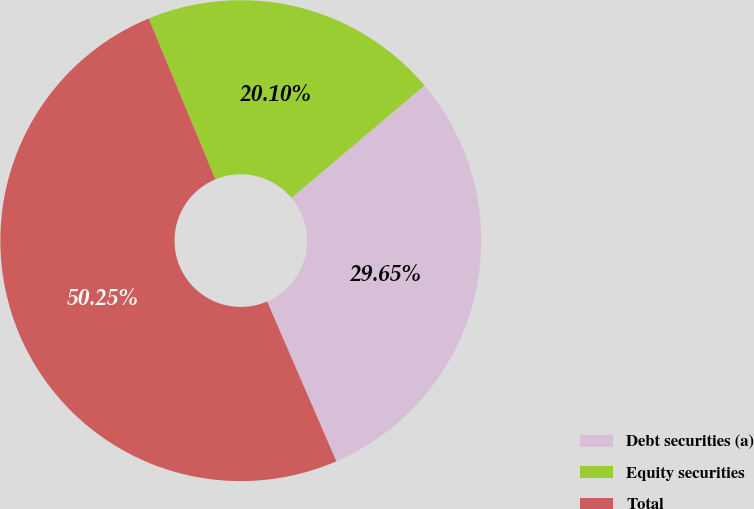Convert chart to OTSL. <chart><loc_0><loc_0><loc_500><loc_500><pie_chart><fcel>Debt securities (a)<fcel>Equity securities<fcel>Total<nl><fcel>29.65%<fcel>20.1%<fcel>50.25%<nl></chart> 